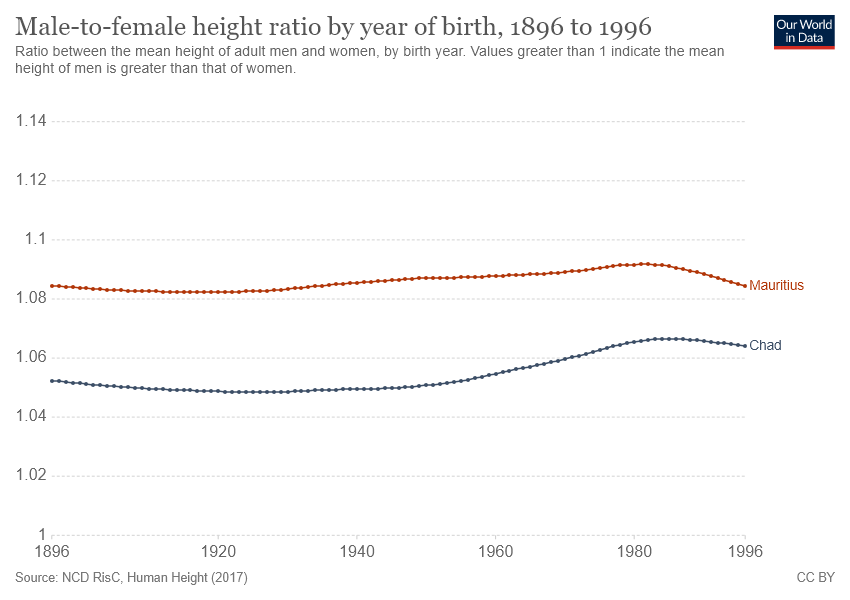Mention a couple of crucial points in this snapshot. It is evident that Mauritius has had a higher male-to-female ratio compared to other countries over the years. The graph compares the GDP per capita of two countries, Mauritius and Chad. 